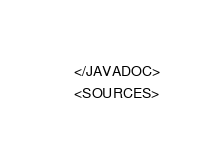Convert code to text. <code><loc_0><loc_0><loc_500><loc_500><_XML_>    </JAVADOC>
    <SOURCES></code> 